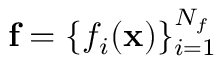Convert formula to latex. <formula><loc_0><loc_0><loc_500><loc_500>f = \{ f _ { i } ( x ) \} _ { i = 1 } ^ { N _ { f } }</formula> 